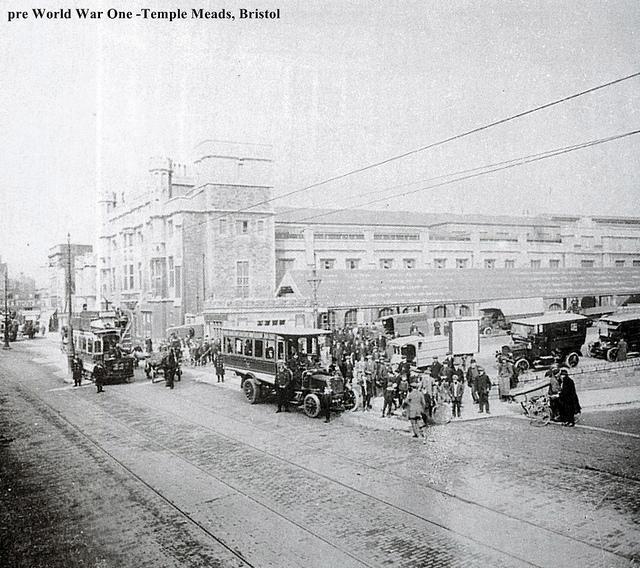How many buses are there?
Give a very brief answer. 2. 